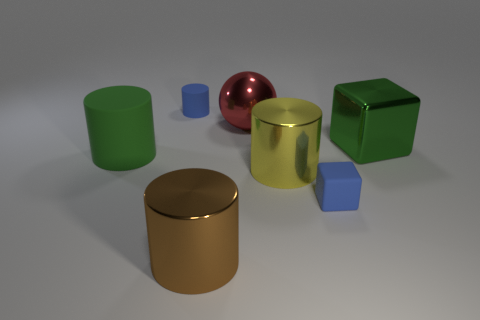The small rubber cylinder has what color?
Keep it short and to the point. Blue. Do the tiny block and the large metallic thing that is right of the tiny cube have the same color?
Your response must be concise. No. Are there any other things that are the same color as the big rubber cylinder?
Ensure brevity in your answer.  Yes. What shape is the big metal thing that is the same color as the large matte thing?
Make the answer very short. Cube. Is the number of tiny blue blocks less than the number of tiny yellow metallic blocks?
Your answer should be compact. No. There is a yellow shiny thing; does it have the same shape as the rubber object behind the big rubber cylinder?
Provide a succinct answer. Yes. Is the size of the block that is behind the yellow object the same as the yellow cylinder?
Ensure brevity in your answer.  Yes. The red thing that is the same size as the brown metal cylinder is what shape?
Offer a terse response. Sphere. Does the big green matte thing have the same shape as the red thing?
Your answer should be very brief. No. What number of large brown things have the same shape as the big green metallic object?
Offer a very short reply. 0. 